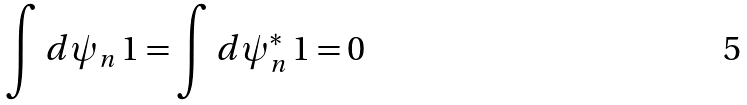<formula> <loc_0><loc_0><loc_500><loc_500>\int d \psi _ { n } \, 1 = \int d \psi ^ { * } _ { n } \, 1 = 0</formula> 